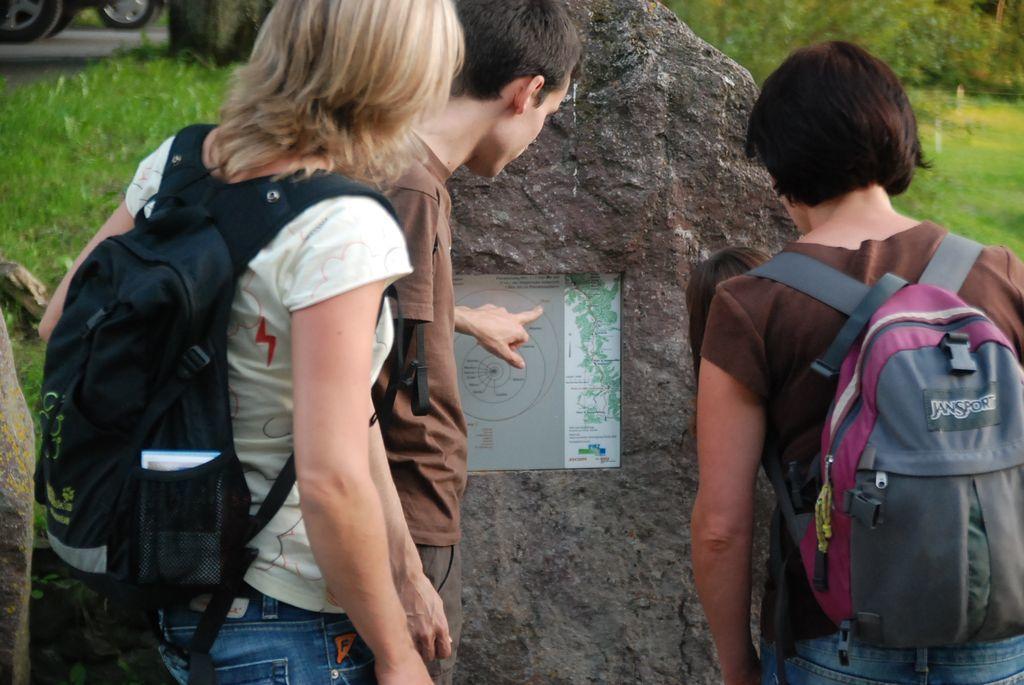Can you describe this image briefly? In the image we can see there are people who are standing and they are carrying backpacks. 